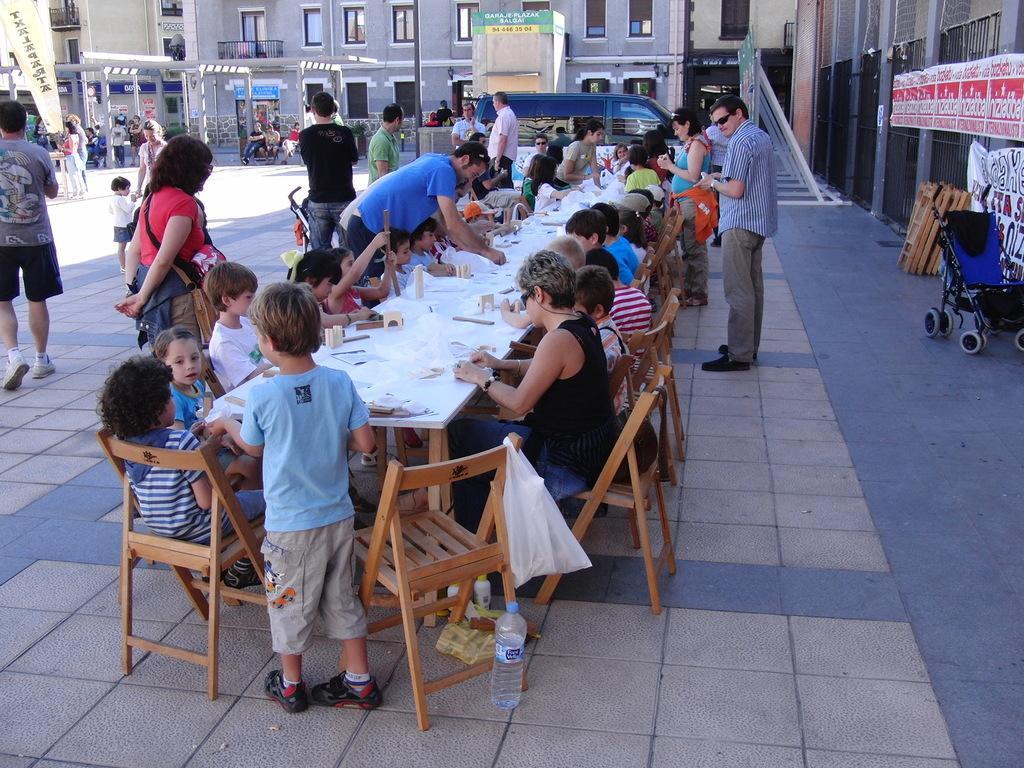Can you describe this image briefly? In the image we can see there are people who are sitting on chairs and few people are standing on the road and behind there are buildings. 